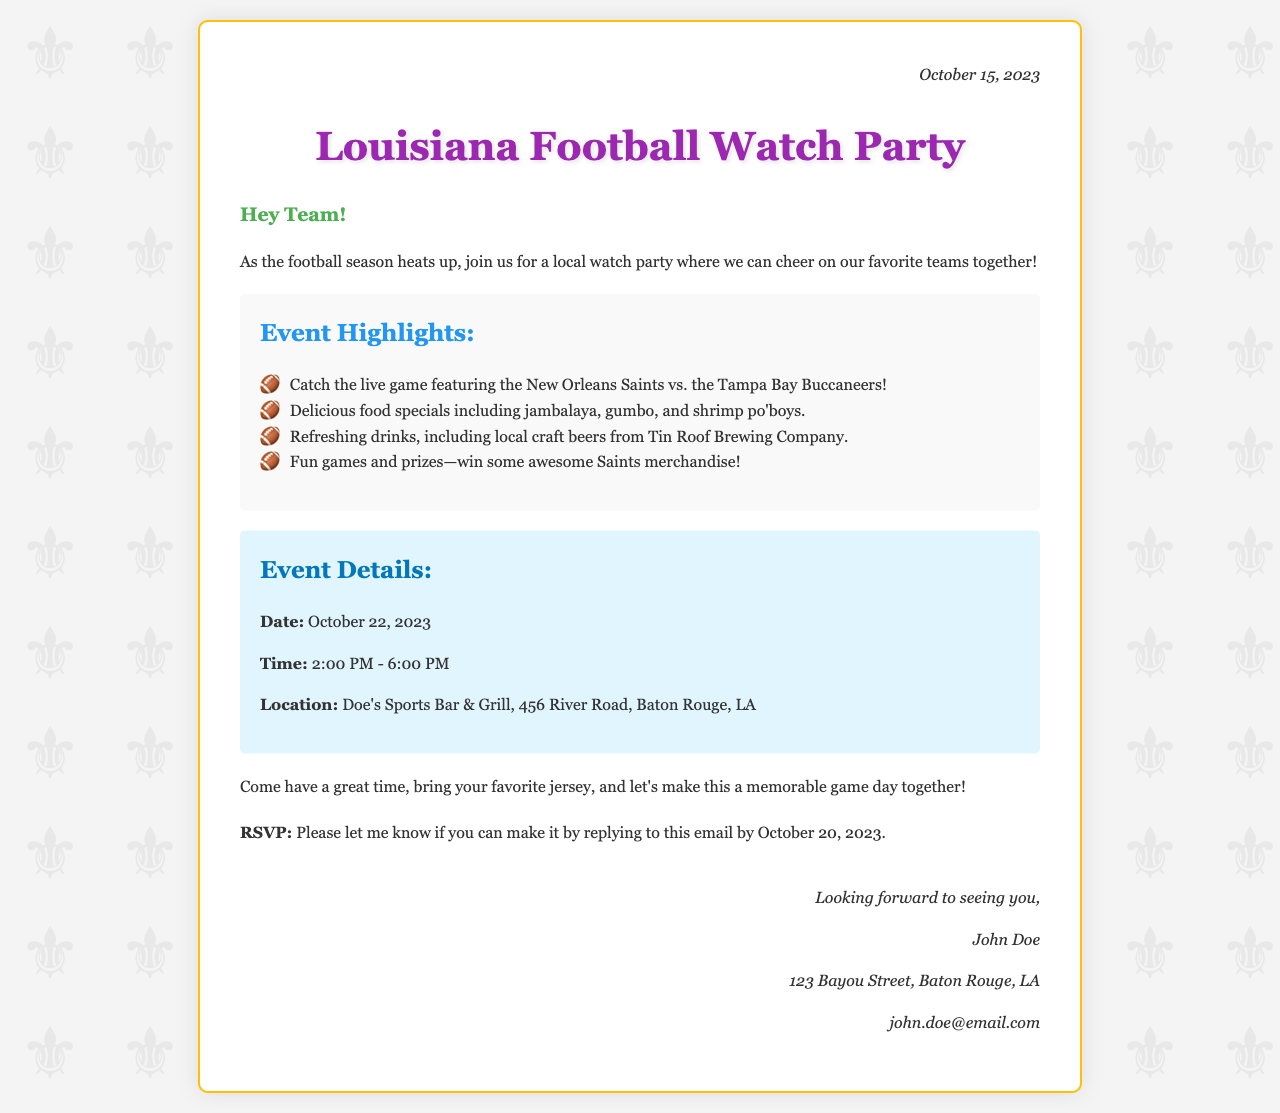What is the date of the watch party? The watch party is scheduled to take place on October 22, 2023.
Answer: October 22, 2023 What time does the event start? The event starts at 2:00 PM as mentioned in the event details.
Answer: 2:00 PM Who are the teams playing in the live game? The document specifies that the game features the New Orleans Saints vs. the Tampa Bay Buccaneers.
Answer: New Orleans Saints vs. Tampa Bay Buccaneers Where is the watch party located? The location is detailed as Doe's Sports Bar & Grill, Baton Rouge, LA.
Answer: Doe's Sports Bar & Grill, Baton Rouge, LA What is the RSVP deadline? The RSVP must be submitted by October 20, 2023 as noted in the RSVP section.
Answer: October 20, 2023 What types of food will be available? The document highlights menu items such as jambalaya, gumbo, and shrimp po'boys.
Answer: jambalaya, gumbo, and shrimp po'boys Who is hosting the event? The signature at the end indicates that John Doe is hosting the watch party.
Answer: John Doe What is the main purpose of the letter? The purpose is to invite people to a local football watch party.
Answer: Invite to a local football watch party 